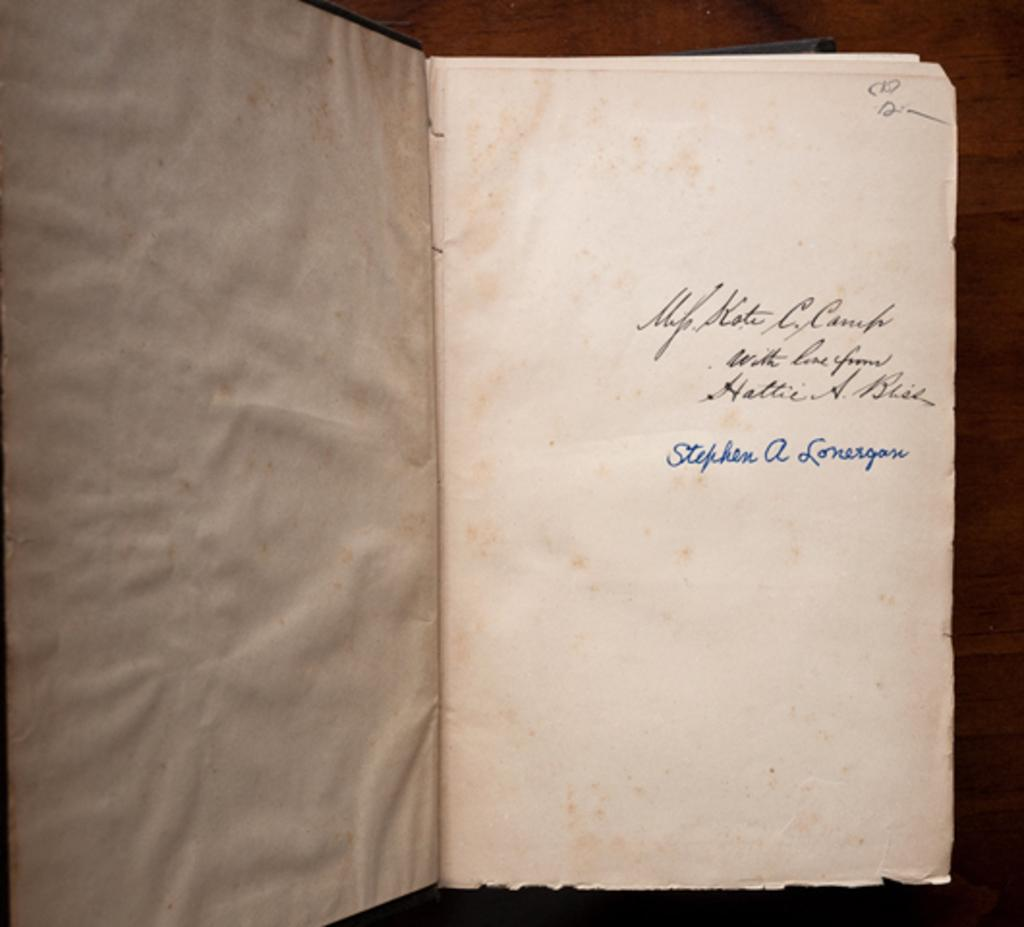<image>
Share a concise interpretation of the image provided. Open book that shows that it was written by Stephen A. Lonergan. 